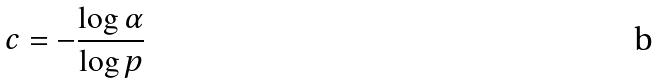<formula> <loc_0><loc_0><loc_500><loc_500>c = - \frac { \log \alpha } { \log p }</formula> 